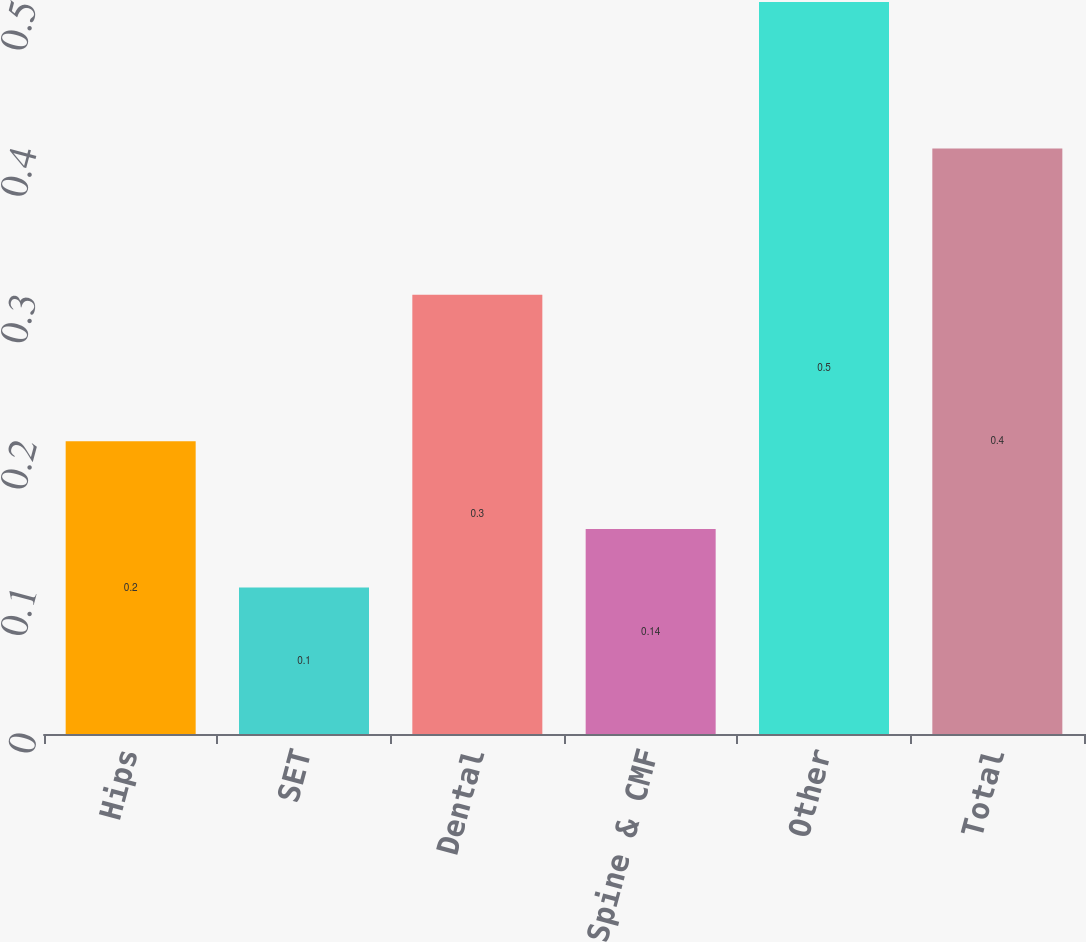Convert chart. <chart><loc_0><loc_0><loc_500><loc_500><bar_chart><fcel>Hips<fcel>SET<fcel>Dental<fcel>Spine & CMF<fcel>Other<fcel>Total<nl><fcel>0.2<fcel>0.1<fcel>0.3<fcel>0.14<fcel>0.5<fcel>0.4<nl></chart> 